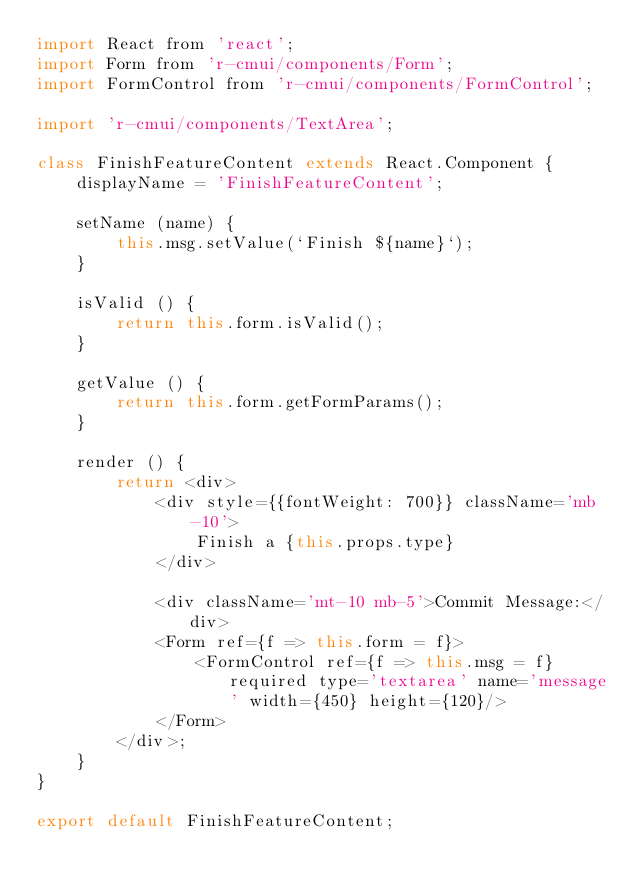<code> <loc_0><loc_0><loc_500><loc_500><_JavaScript_>import React from 'react';
import Form from 'r-cmui/components/Form';
import FormControl from 'r-cmui/components/FormControl';

import 'r-cmui/components/TextArea';

class FinishFeatureContent extends React.Component {
    displayName = 'FinishFeatureContent';

    setName (name) {
        this.msg.setValue(`Finish ${name}`);
    }

    isValid () {
        return this.form.isValid();
    }

    getValue () {
        return this.form.getFormParams();
    }

    render () {
        return <div>
            <div style={{fontWeight: 700}} className='mb-10'>
                Finish a {this.props.type}
            </div>

            <div className='mt-10 mb-5'>Commit Message:</div>
            <Form ref={f => this.form = f}>
                <FormControl ref={f => this.msg = f} required type='textarea' name='message' width={450} height={120}/>
            </Form>
        </div>;
    }
}

export default FinishFeatureContent;
</code> 